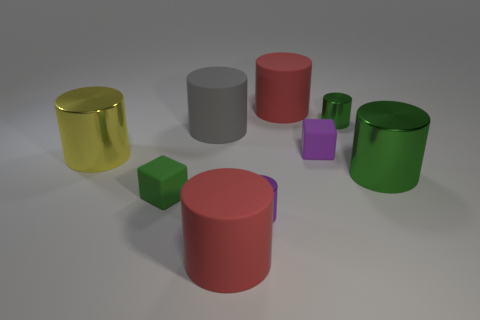Is there a pattern to the arrangement of these objects? While the objects are casually arranged, one could observe an alternating pattern of cylinders and cubes, as well as a progression of sizes that goes from larger to smaller, then back to larger again. 